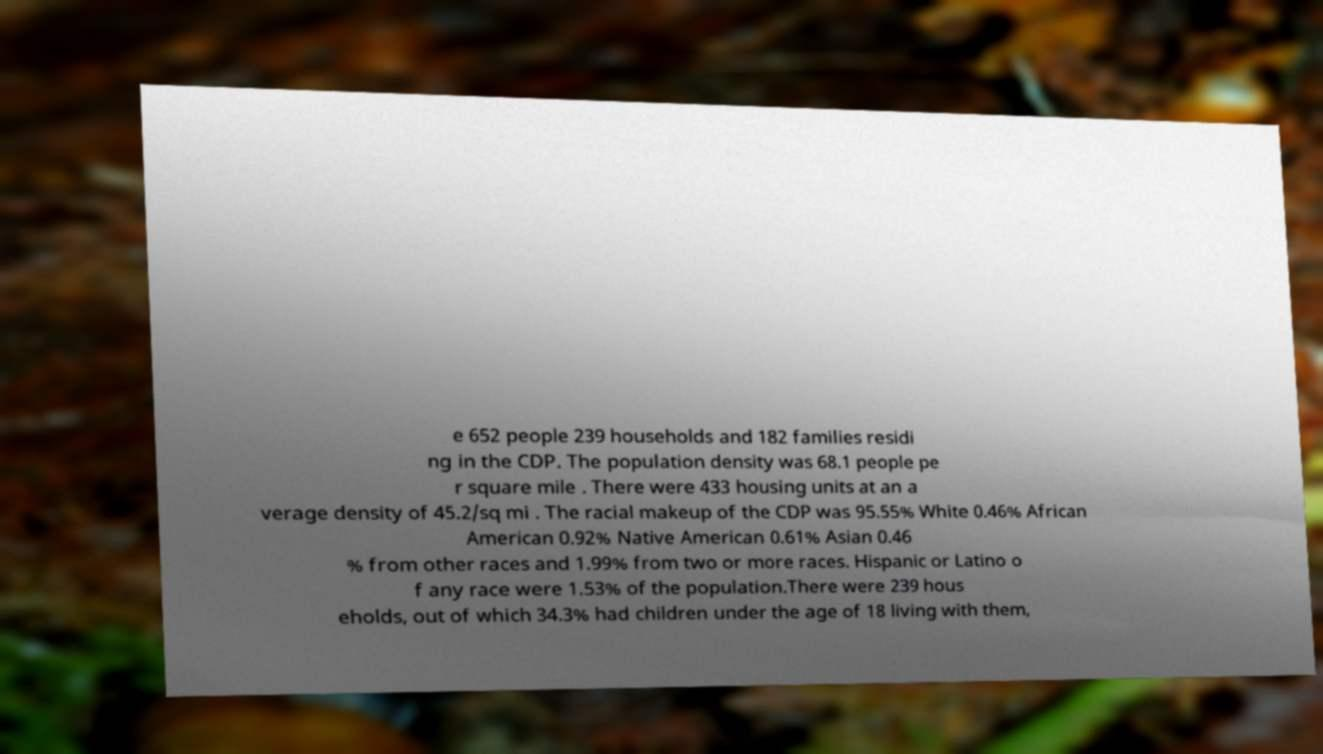Could you extract and type out the text from this image? e 652 people 239 households and 182 families residi ng in the CDP. The population density was 68.1 people pe r square mile . There were 433 housing units at an a verage density of 45.2/sq mi . The racial makeup of the CDP was 95.55% White 0.46% African American 0.92% Native American 0.61% Asian 0.46 % from other races and 1.99% from two or more races. Hispanic or Latino o f any race were 1.53% of the population.There were 239 hous eholds, out of which 34.3% had children under the age of 18 living with them, 